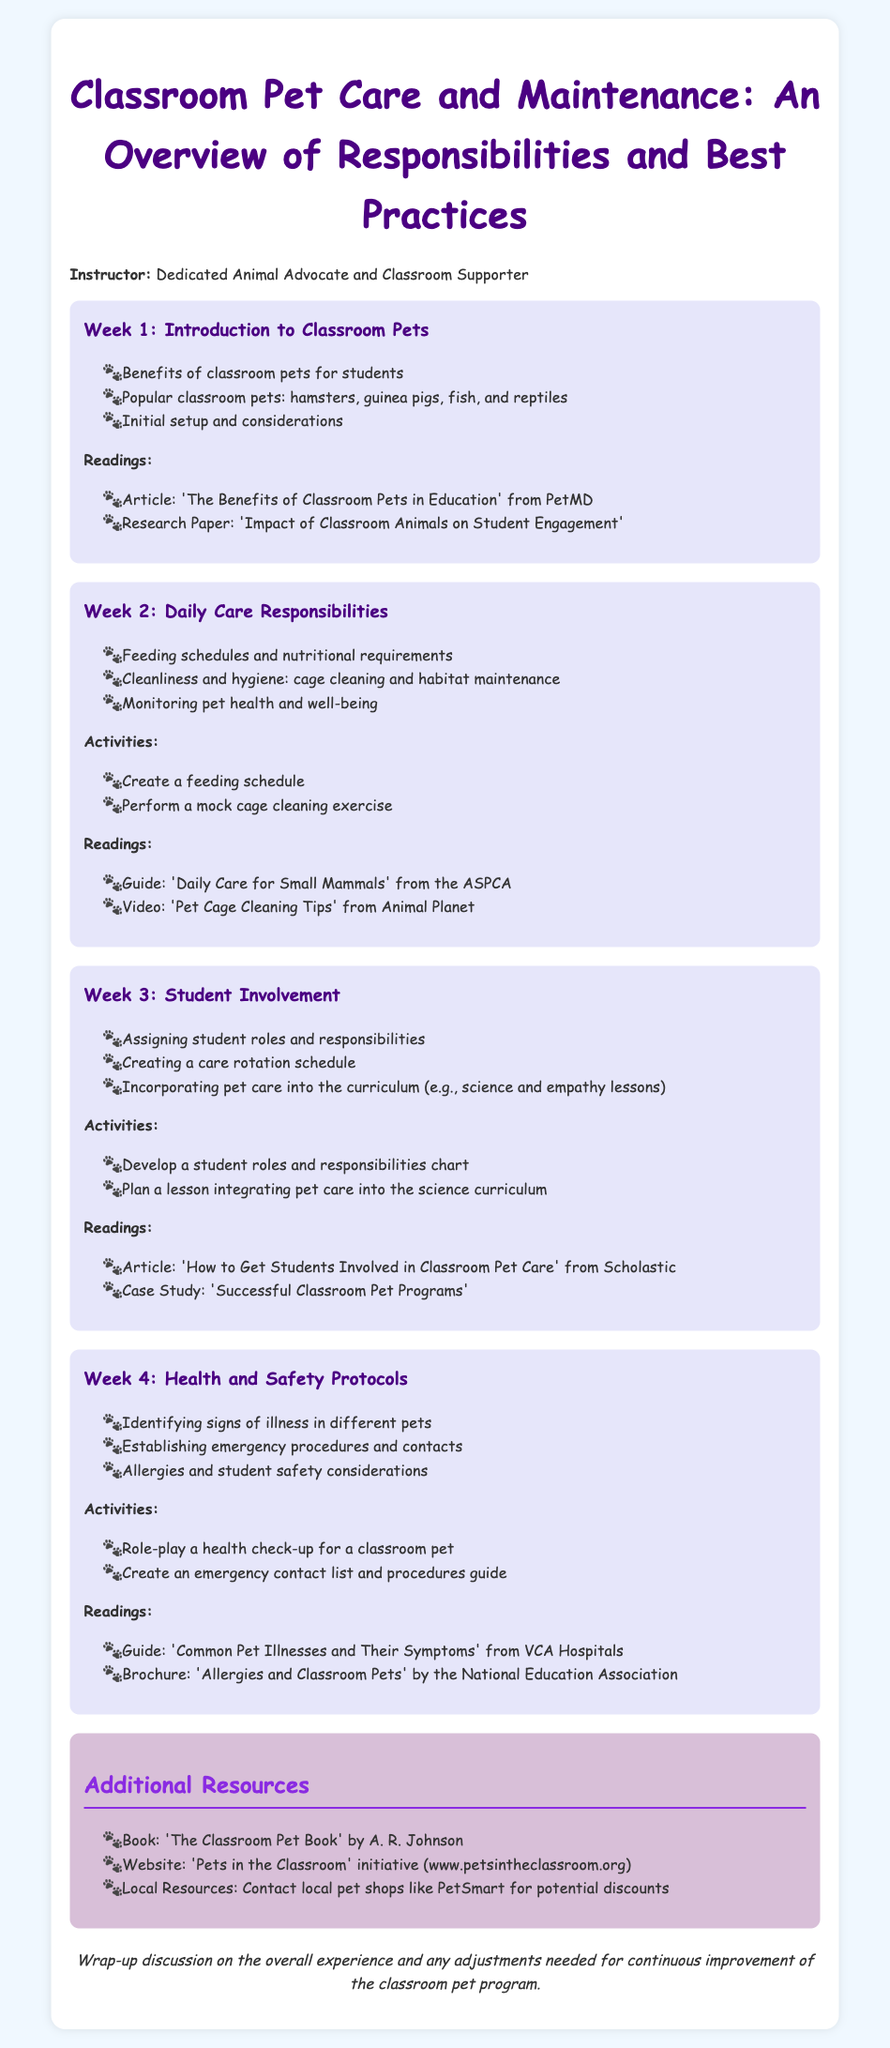What is the title of the syllabus? The title of the syllabus is stated at the top of the document.
Answer: Classroom Pet Care and Maintenance: An Overview of Responsibilities and Best Practices Who is the instructor for the course? The instructor's name is mentioned in the introduction of the syllabus.
Answer: Dedicated Animal Advocate and Classroom Supporter What is covered in Week 2? Week 2's content is detailed in the specific section for that week, focusing on daily care responsibilities.
Answer: Daily Care Responsibilities How many weeks are outlined in the syllabus? The number of weeks can be counted from the different sections presented in the document.
Answer: 4 What type of pets are discussed in Week 1? The specific pet types are listed in the week’s section about classroom pets.
Answer: Hamsters, guinea pigs, fish, and reptiles What activity is suggested for Week 4? The activities section for Week 4 describes what students can engage in regarding health and safety protocols.
Answer: Role-play a health check-up for a classroom pet How many readings are included in Week 3? The readings listed for Week 3 indicate how many resources are provided for that week.
Answer: 2 What is an additional resource mentioned in the document? Additional resources are listed towards the end of the syllabus, including a book and website.
Answer: The Classroom Pet Book by A. R. Johnson What is the color theme of the syllabus? The document's colors and styling can be observed throughout the layout.
Answer: Light and pastel colors 